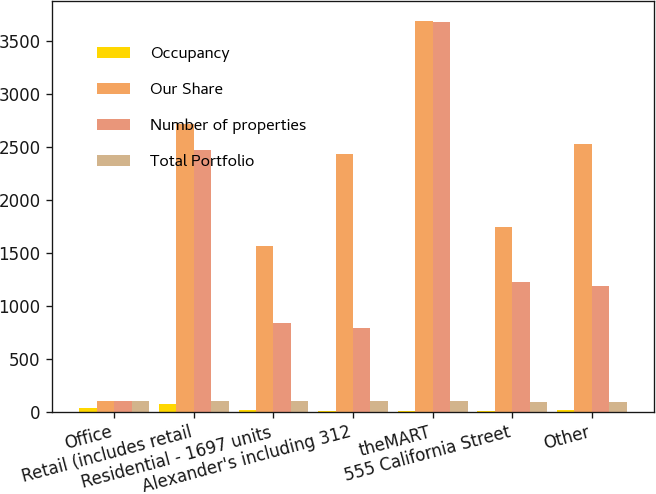<chart> <loc_0><loc_0><loc_500><loc_500><stacked_bar_chart><ecel><fcel>Office<fcel>Retail (includes retail<fcel>Residential - 1697 units<fcel>Alexander's including 312<fcel>theMART<fcel>555 California Street<fcel>Other<nl><fcel>Occupancy<fcel>36<fcel>71<fcel>11<fcel>7<fcel>3<fcel>3<fcel>11<nl><fcel>Our Share<fcel>98.95<fcel>2720<fcel>1568<fcel>2437<fcel>3689<fcel>1741<fcel>2525<nl><fcel>Number of properties<fcel>98.95<fcel>2471<fcel>835<fcel>790<fcel>3680<fcel>1219<fcel>1188<nl><fcel>Total Portfolio<fcel>97.1<fcel>96.9<fcel>96.7<fcel>99.3<fcel>98.6<fcel>94.2<fcel>93.6<nl></chart> 